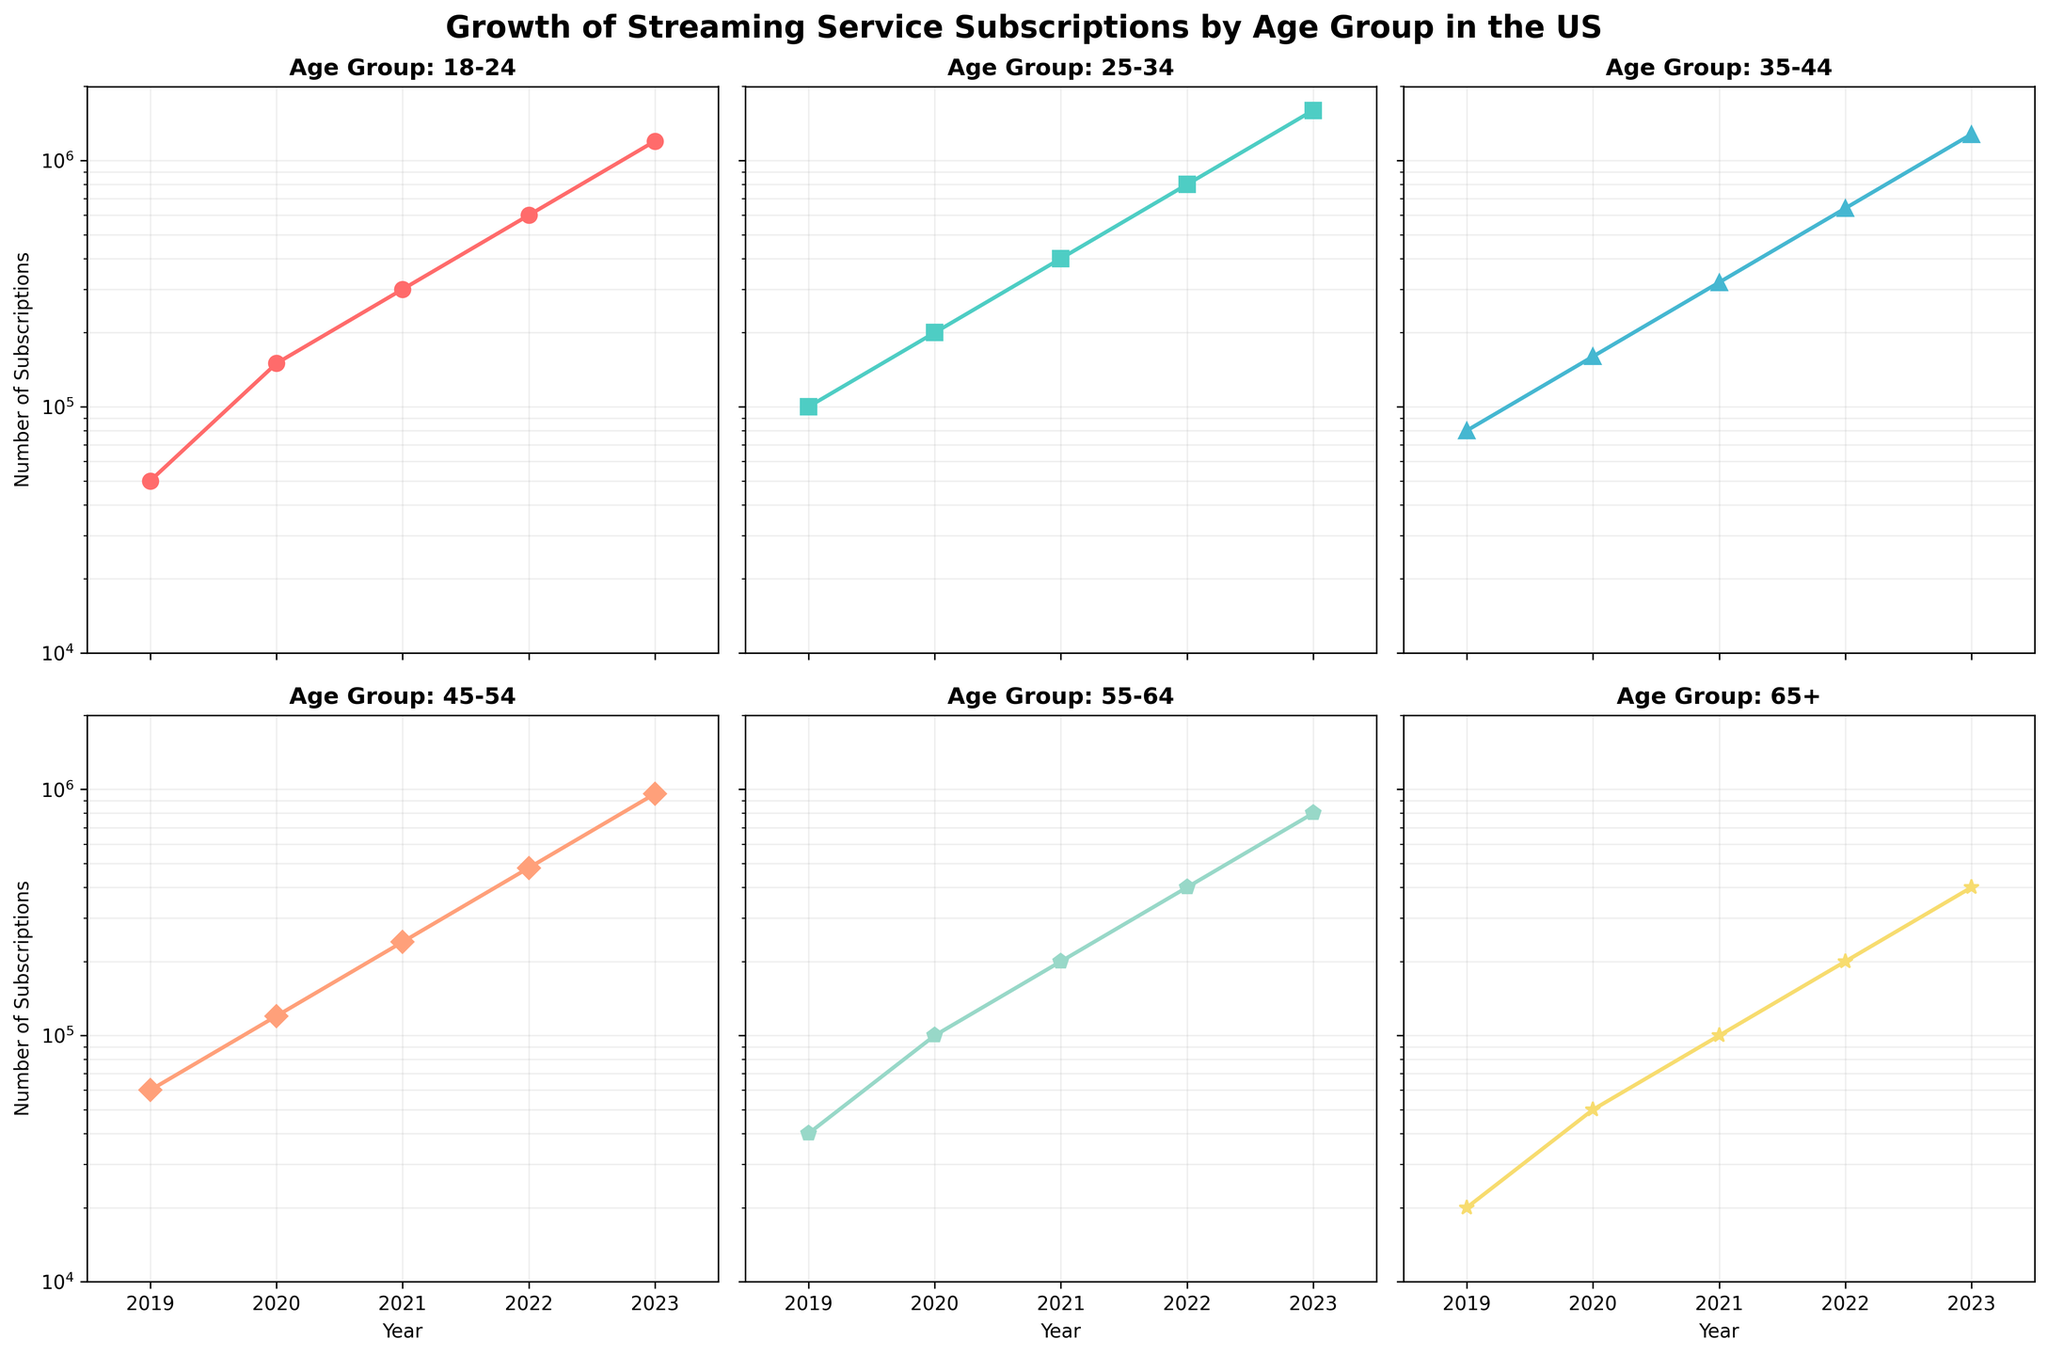What is the title of the figure? The title of the figure is displayed at the top in bold and informs us about the content of the plots. It states, "Growth of Streaming Service Subscriptions by Age Group in the US".
Answer: Growth of Streaming Service Subscriptions by Age Group in the US Which age group had the highest number of subscriptions in 2023? Look at the individual subplots for each age group and compare the data points for the year 2023, which are in a log scale. The age group 25-34 shows the highest value in 2023.
Answer: 25-34 What is the range of years shown in the x-axis of the plots? Examine the x-axis of any of the subplots. It starts at 2019 and ends at 2023.
Answer: 2019-2023 How many age groups are analyzed in the figure? There are six subplots corresponding to six different age groups. Counting each subplot gives us a total of six age groups.
Answer: 6 Which age groups show a steady increase in subscriptions every year? Review the curves in each subplot to determine which ones have a monotonically increasing trend each year. All age groups (18-24, 25-34, 35-44, 45-54, 55-64, 65+) show a steady increase yearly.
Answer: All age groups In which year did the 18-24 age group reach 600,000 subscriptions? Examine the plot for the 18-24 age group and find the point where the curve hits 600,000 on the y-axis. This occurs in the year 2022.
Answer: 2022 How many subscriptions did the 45-54 age group have in 2019? Look at the subplot for the 45-54 age group and find the data point corresponding to the year 2019 on the x-axis. The number of subscriptions is 60,000.
Answer: 60,000 Which age group has the lowest growth rate relative to its starting point in 2019? To determine this, compare the fine slopes of the curves relative to their 2019 values. The 65+ age group has the lowest initial value and grows at a slower rate compared to others.
Answer: 65+ What is the approximate overall trend seen in the subplots? By reviewing all subplots collectively, the overall trend observed is a consistent, exponential growth in the number of streaming service subscriptions across all age groups.
Answer: Exponential growth By how many times did the number of subscriptions in the 25-34 age group increase from 2019 to 2023? For the 25-34 age group, the number of subscriptions in 2019 was 100,000 and in 2023 it was 1,600,000. The increase factor is 1,600,000 / 100,000, which equals 16 times.
Answer: 16 times 